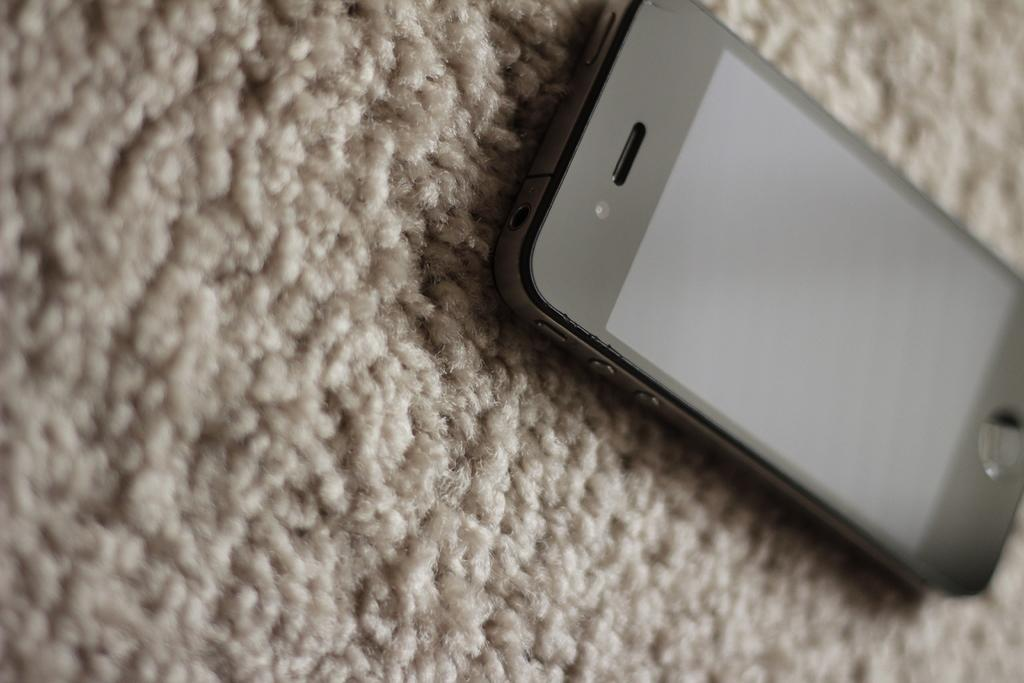What electronic device is visible in the image? There is a mobile phone in the image. Where is the mobile phone located in the image? The mobile phone is on the right side of the image. What is the mobile phone placed on in the image? The mobile phone is on a mat. Can you see any stars in the image? There are no stars visible in the image. Is there a baseball game happening in the image? There is no baseball game present in the image. 